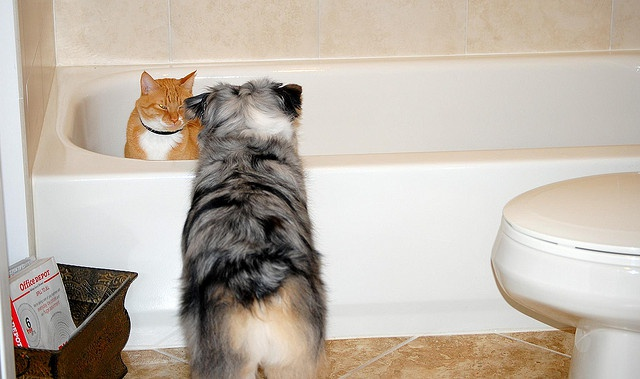Describe the objects in this image and their specific colors. I can see dog in lightgray, gray, black, and darkgray tones, toilet in lightgray, darkgray, and tan tones, cat in lightgray, red, and tan tones, and book in lightgray, darkgray, red, pink, and gray tones in this image. 